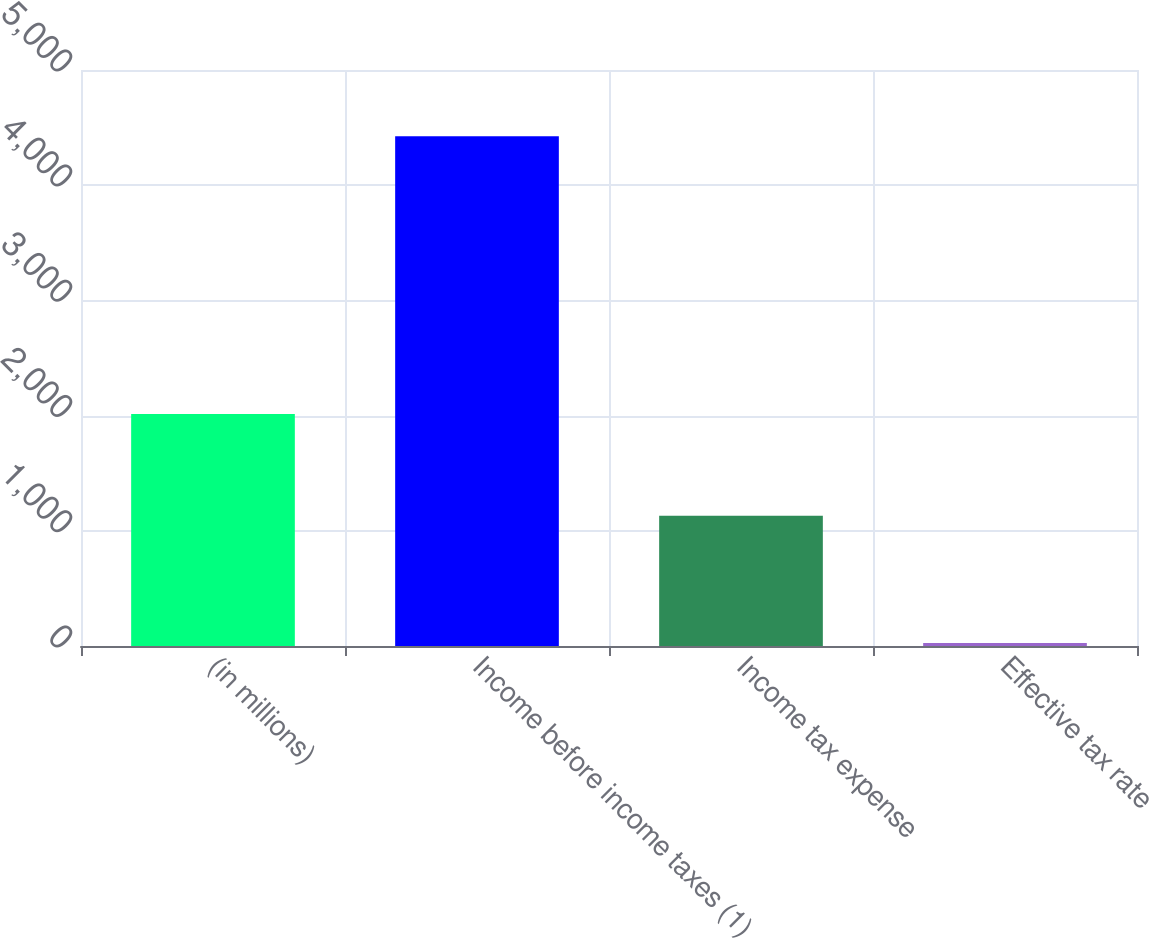Convert chart. <chart><loc_0><loc_0><loc_500><loc_500><bar_chart><fcel>(in millions)<fcel>Income before income taxes (1)<fcel>Income tax expense<fcel>Effective tax rate<nl><fcel>2014<fcel>4425<fcel>1131<fcel>25.6<nl></chart> 